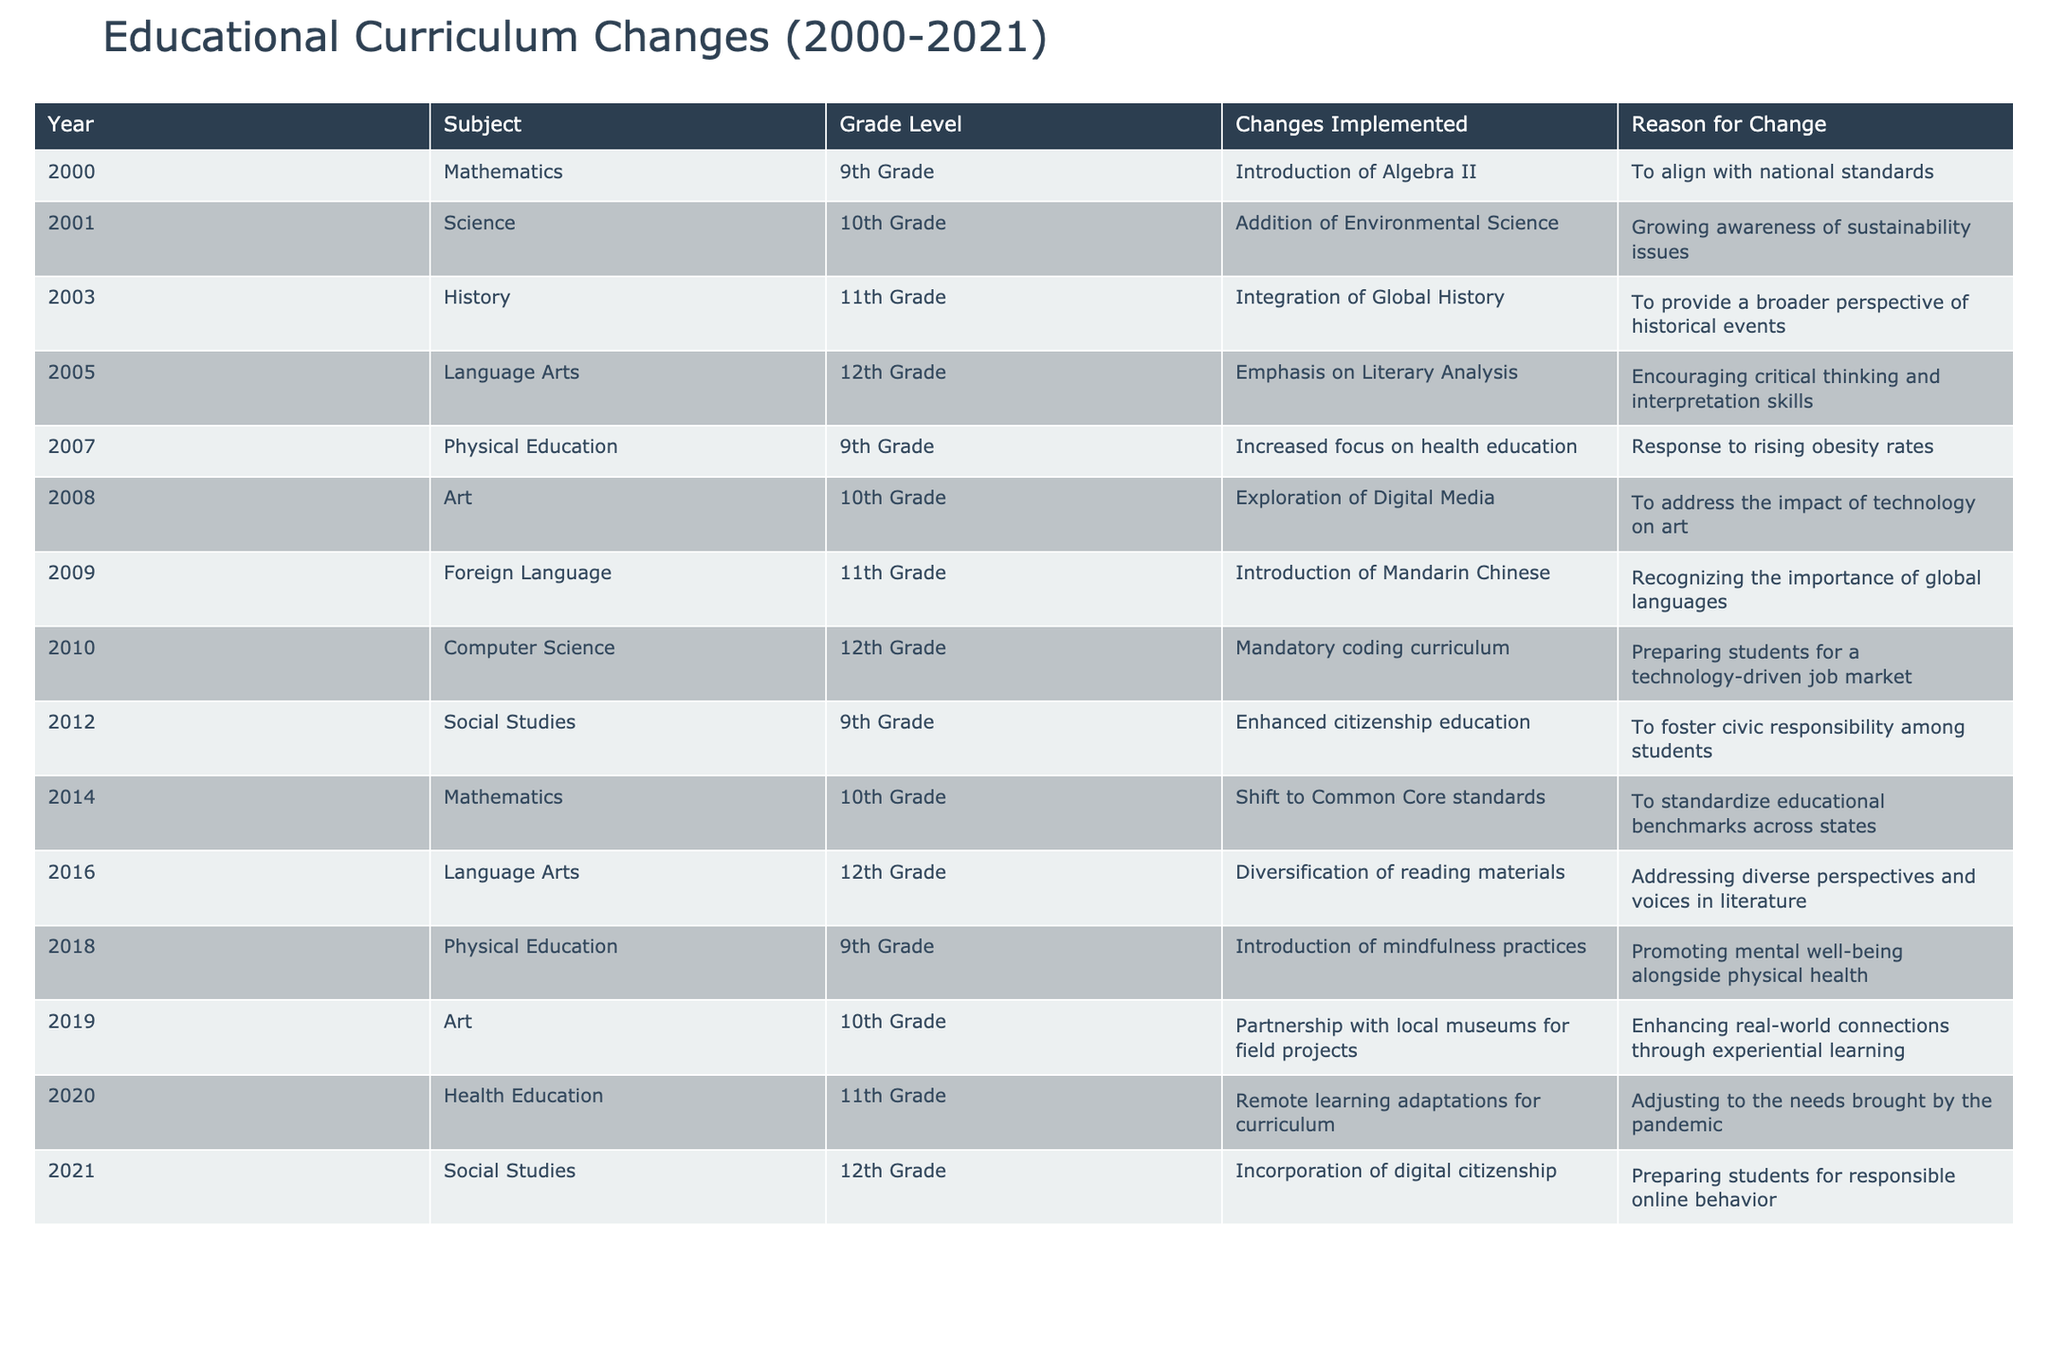What changes were implemented in Physical Education for 9th Grade in 2018? According to the table, in 2018, the change in Physical Education for 9th Grade was the introduction of mindfulness practices.
Answer: Introduction of mindfulness practices Which subject had a change related to digital citizenship and in which year? The subject that had a change related to digital citizenship was Social Studies, and the change occurred in 2021.
Answer: Social Studies, 2021 How many subjects experienced a change in 10th Grade? By reviewing the table, there are four subjects that experienced changes in 10th Grade: Science, Art, Mathematics, and Physical Education.
Answer: Four In which year was the shift to Common Core standards in Mathematics? The table specifies that the shift to Common Core standards in Mathematics occurred in 2014.
Answer: 2014 Did the introduction of Mandarin Chinese occur before or after 2009? The table indicates that the introduction of Mandarin Chinese was implemented in 2009, so it occurred in the year itself (not before or after).
Answer: In 2009 Which change was made to Language Arts in 2016, and what was its reason? In 2016, Language Arts saw a diversification of reading materials implemented to address diverse perspectives and voices in literature.
Answer: Diversification of reading materials; to address diverse perspectives What is the trend in curriculum changes regarding the health education topic from 2007 to 2021? Over the years, there has been a rising emphasis on health education. In 2007, the focus was on increased health education, and in 2020, adaptations were made for remote learning, indicating a shift towards modern health education needs.
Answer: Increased focus on health, adapting to modern needs Which subject had changes in both 2001 and 2009, and what were they? The subject Science had a change in 2001 with the addition of Environmental Science and in 2009 with the introduction of Mandarin Chinese as a Foreign Language.
Answer: Science; 2001: Environmental Science, 2009: Mandarin Chinese What is the main reason for the integration of Global History in 2003? The main reason for integrating Global History in 2003 was to provide a broader perspective of historical events.
Answer: To provide a broader perspective of historical events How many years passed between the introduction of Algebra II and the addition of Environmental Science? The introduction of Algebra II was in 2000, and the addition of Environmental Science occurred in 2001. Thus, only one year passed between these changes.
Answer: One year Which change occurred in the 11th Grade curriculum specifically related to health during the pandemic? In 2020, the change related to health in the 11th Grade curriculum was the implementation of remote learning adaptations for health education.
Answer: Remote learning adaptations for health education 